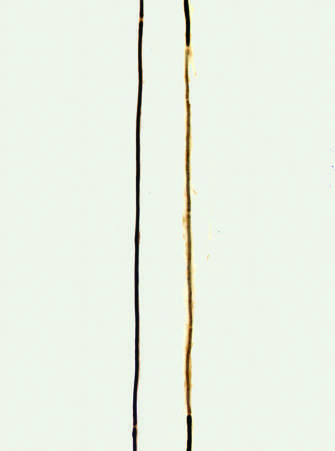what do teased fiber preparations allow for?
Answer the question using a single word or phrase. Examination of individual axons of peripheral nerves 